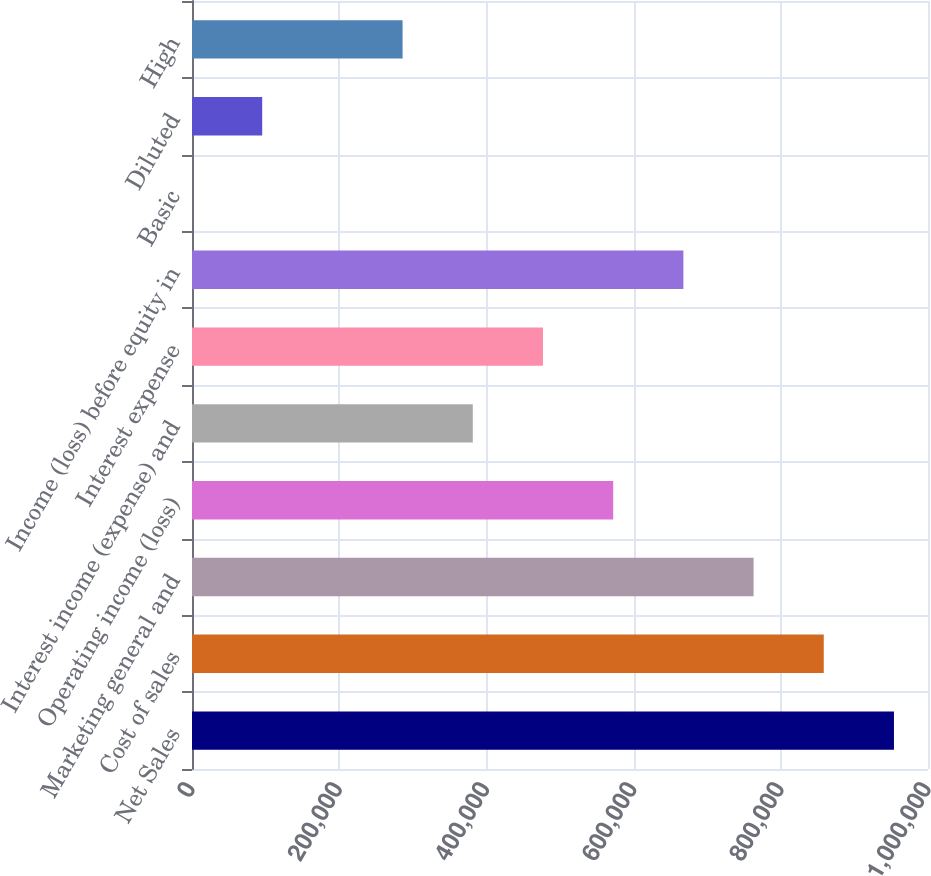<chart> <loc_0><loc_0><loc_500><loc_500><bar_chart><fcel>Net Sales<fcel>Cost of sales<fcel>Marketing general and<fcel>Operating income (loss)<fcel>Interest income (expense) and<fcel>Interest expense<fcel>Income (loss) before equity in<fcel>Basic<fcel>Diluted<fcel>High<nl><fcel>953759<fcel>858383<fcel>763007<fcel>572255<fcel>381504<fcel>476880<fcel>667631<fcel>0.09<fcel>95376<fcel>286128<nl></chart> 